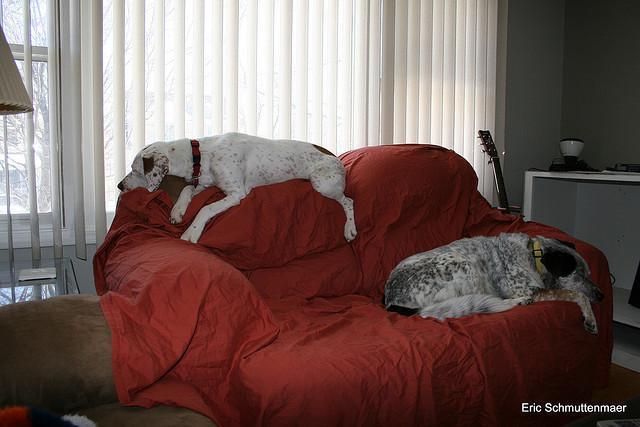How many dogs are there?
Give a very brief answer. 2. How many people are in this picture?
Give a very brief answer. 0. 